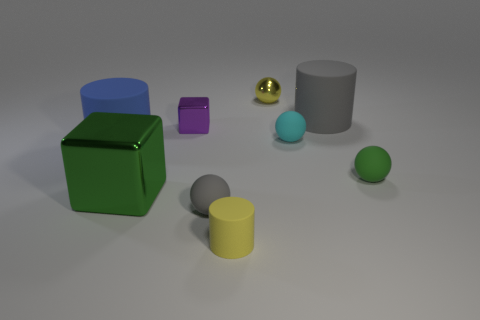Is the number of big gray things greater than the number of small yellow objects?
Give a very brief answer. No. There is a gray thing that is behind the green sphere; is its size the same as the small gray thing?
Give a very brief answer. No. What number of small objects have the same color as the small metallic ball?
Your response must be concise. 1. Does the green matte object have the same shape as the small gray matte object?
Ensure brevity in your answer.  Yes. The green thing that is the same shape as the tiny purple object is what size?
Provide a succinct answer. Large. Is the number of rubber cylinders in front of the big green cube greater than the number of tiny cyan matte balls left of the small cyan matte sphere?
Give a very brief answer. Yes. Does the large green block have the same material as the gray object left of the tiny yellow shiny ball?
Give a very brief answer. No. What color is the rubber sphere that is to the right of the tiny yellow metal ball and to the left of the tiny green matte object?
Ensure brevity in your answer.  Cyan. The tiny rubber object that is behind the tiny green matte sphere has what shape?
Offer a very short reply. Sphere. How big is the green thing that is to the left of the tiny matte ball left of the tiny shiny object behind the gray rubber cylinder?
Give a very brief answer. Large. 